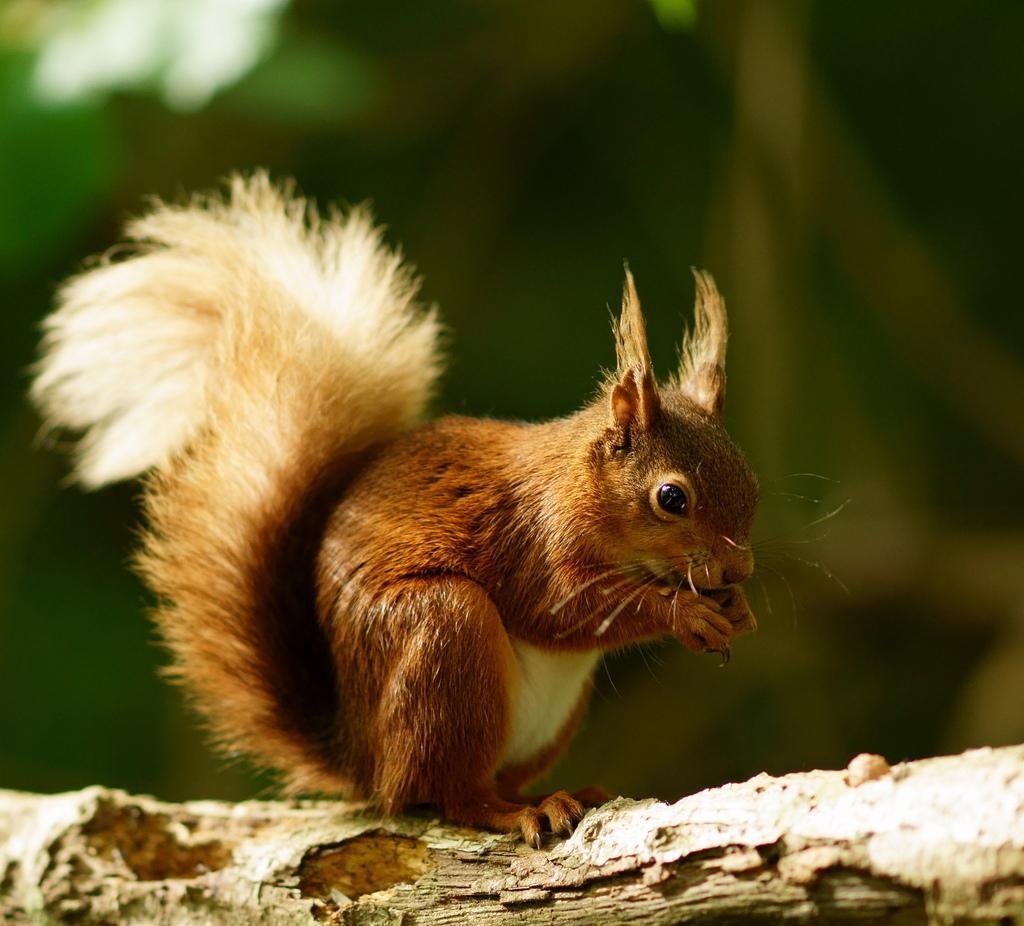In one or two sentences, can you explain what this image depicts? In this image I can see a squirrel which is brown, cream and black in color on a tree branch. I can see the blurry background which is green in color. 